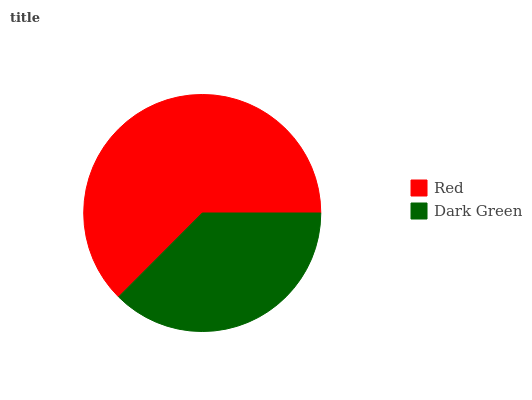Is Dark Green the minimum?
Answer yes or no. Yes. Is Red the maximum?
Answer yes or no. Yes. Is Dark Green the maximum?
Answer yes or no. No. Is Red greater than Dark Green?
Answer yes or no. Yes. Is Dark Green less than Red?
Answer yes or no. Yes. Is Dark Green greater than Red?
Answer yes or no. No. Is Red less than Dark Green?
Answer yes or no. No. Is Red the high median?
Answer yes or no. Yes. Is Dark Green the low median?
Answer yes or no. Yes. Is Dark Green the high median?
Answer yes or no. No. Is Red the low median?
Answer yes or no. No. 